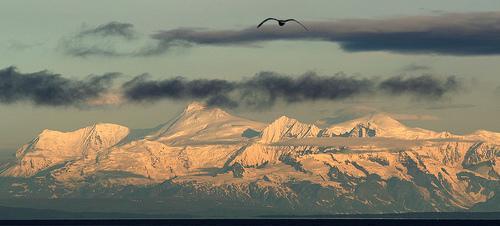How many birds?
Give a very brief answer. 1. 